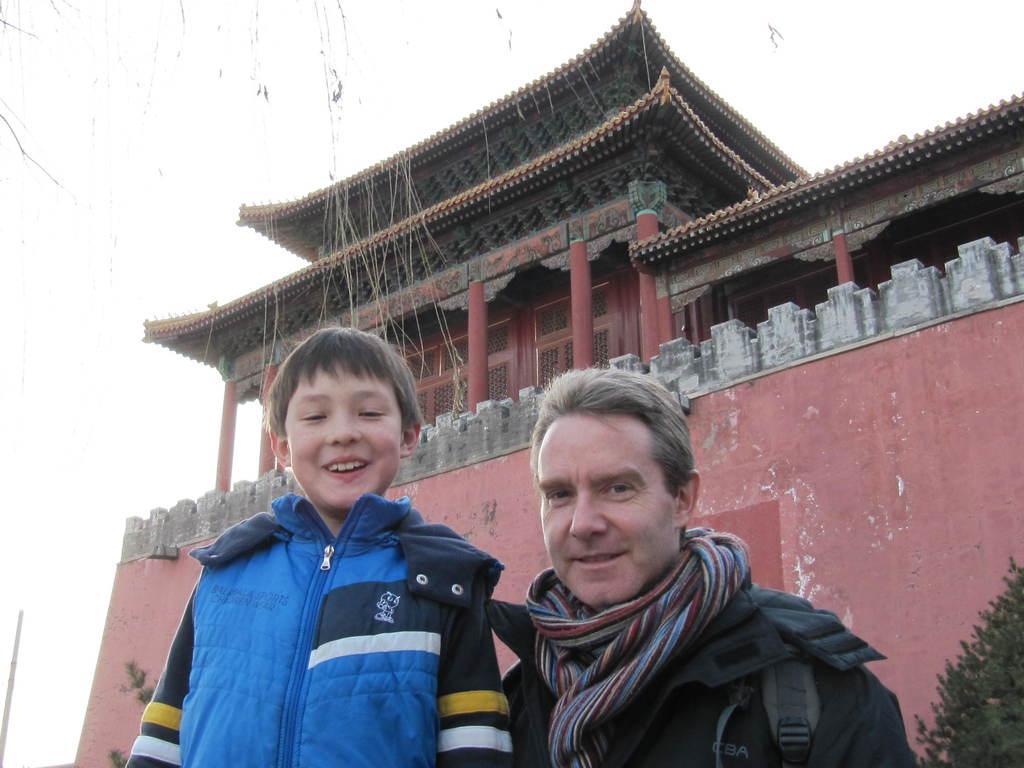In one or two sentences, can you explain what this image depicts? In this image, there is an outside view. There is a building in the middle of the image. There is a person and kid wearing clothes at the bottom of the image. There is a sky at the top of the image. 